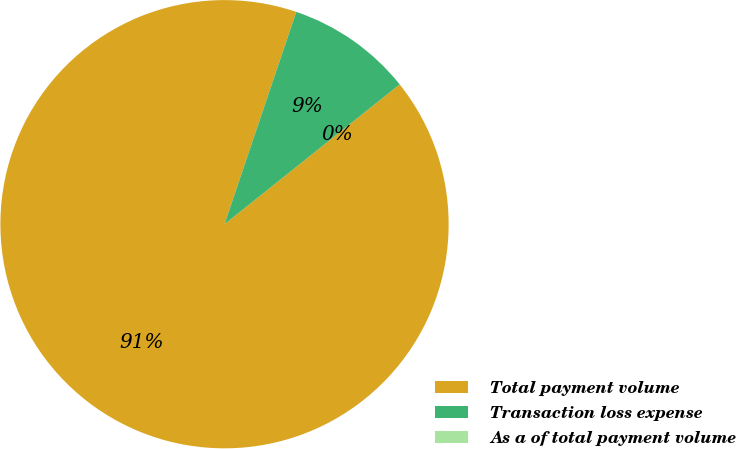<chart> <loc_0><loc_0><loc_500><loc_500><pie_chart><fcel>Total payment volume<fcel>Transaction loss expense<fcel>As a of total payment volume<nl><fcel>90.91%<fcel>9.09%<fcel>0.0%<nl></chart> 